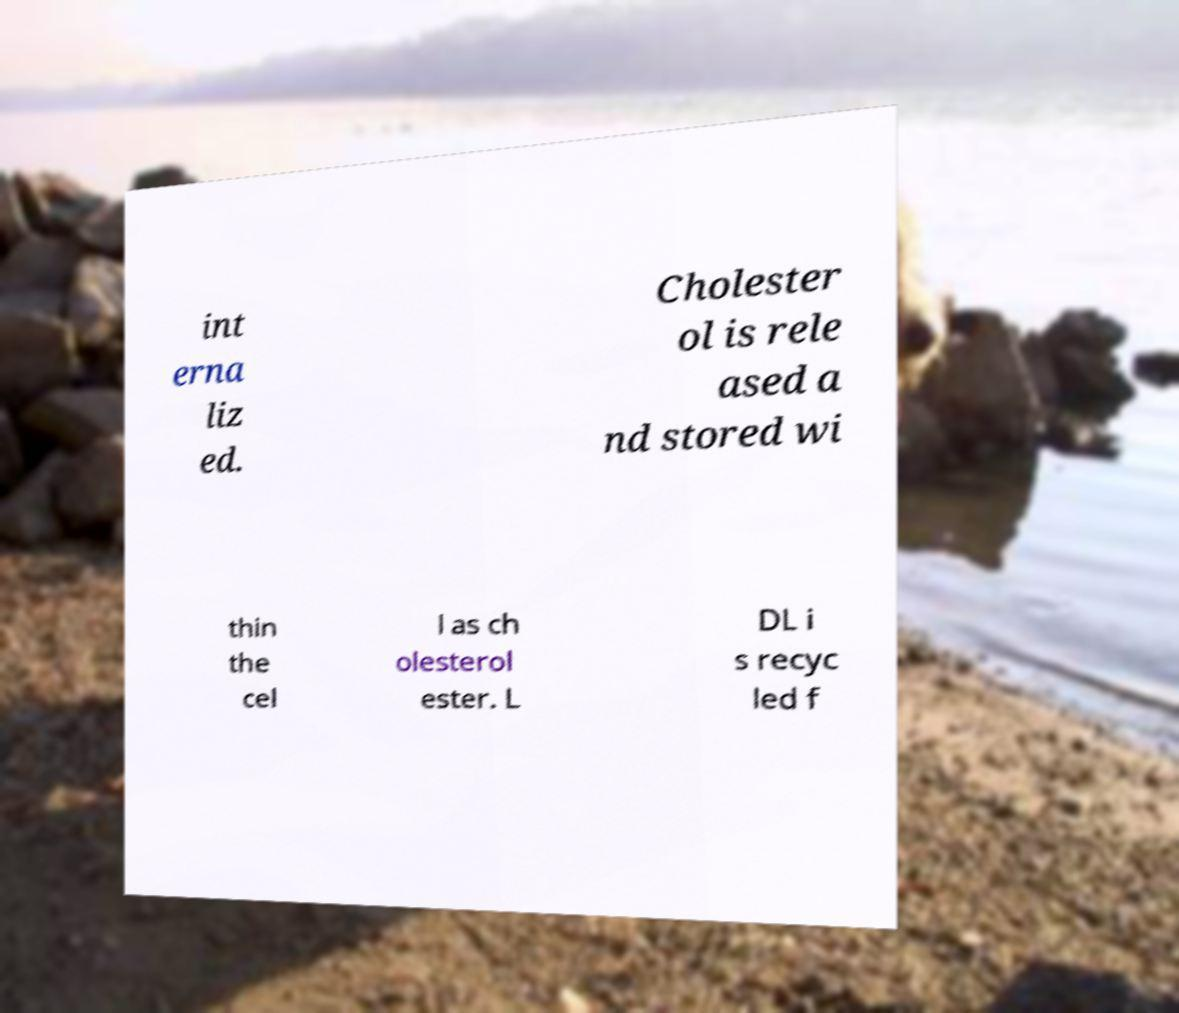Please read and relay the text visible in this image. What does it say? int erna liz ed. Cholester ol is rele ased a nd stored wi thin the cel l as ch olesterol ester. L DL i s recyc led f 